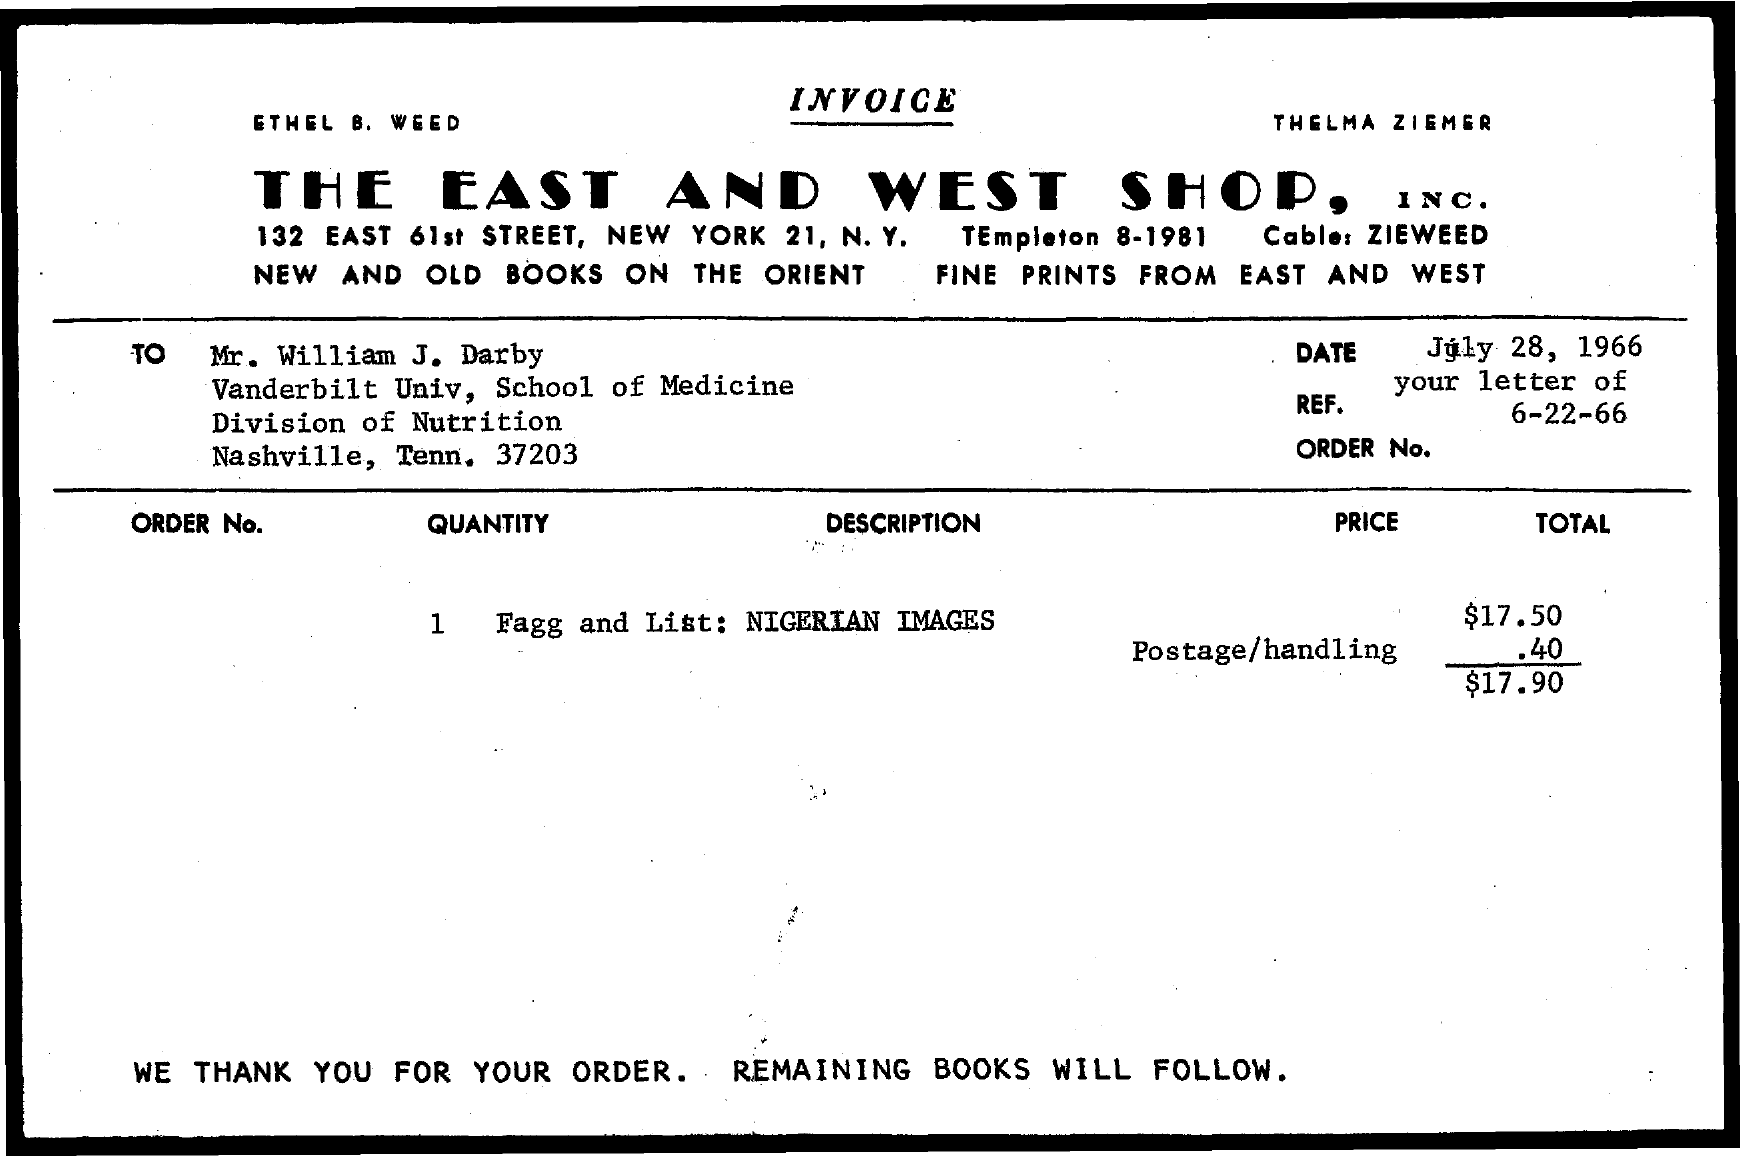Mention a couple of crucial points in this snapshot. The payee's name on the invoice is "Mr. William J. Darby. The total invoice amount given is $17.90. The company responsible for issuing the invoice is THE EAST AND WEST SHOP, INC. The description of the quantity mentioned in the invoice is "Nigerian Images. 